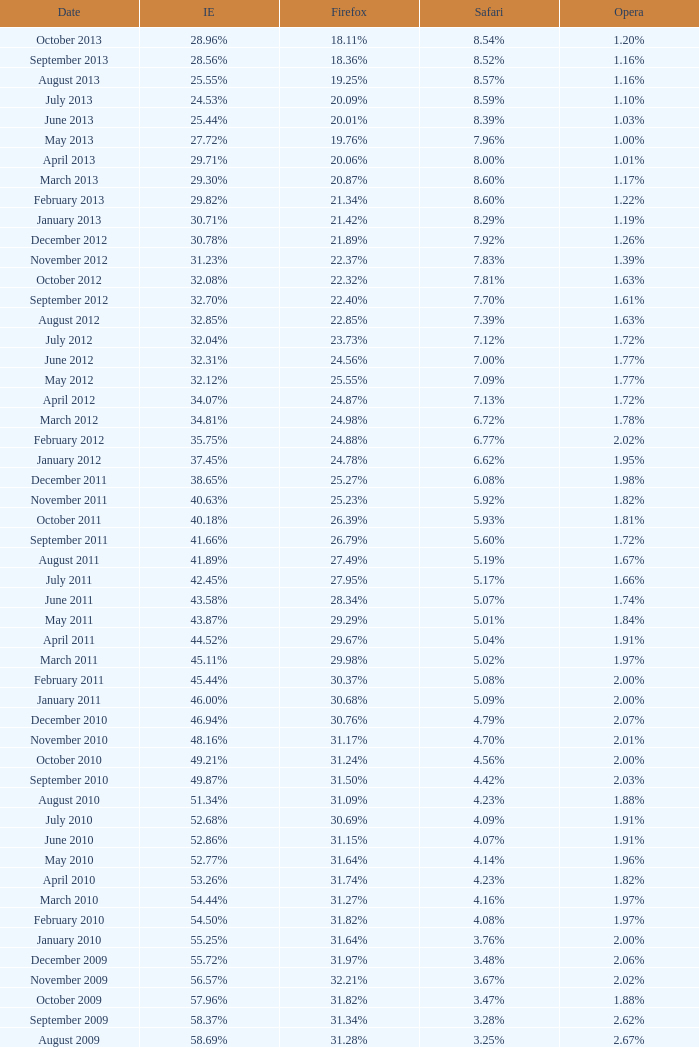What percentage of browsers were using Opera in November 2009? 2.02%. 